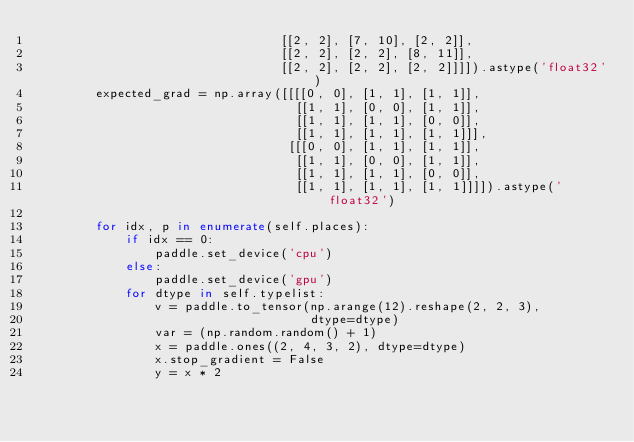<code> <loc_0><loc_0><loc_500><loc_500><_Python_>                                 [[2, 2], [7, 10], [2, 2]],
                                 [[2, 2], [2, 2], [8, 11]],
                                 [[2, 2], [2, 2], [2, 2]]]]).astype('float32')
        expected_grad = np.array([[[[0, 0], [1, 1], [1, 1]],
                                   [[1, 1], [0, 0], [1, 1]],
                                   [[1, 1], [1, 1], [0, 0]],
                                   [[1, 1], [1, 1], [1, 1]]],
                                  [[[0, 0], [1, 1], [1, 1]],
                                   [[1, 1], [0, 0], [1, 1]],
                                   [[1, 1], [1, 1], [0, 0]],
                                   [[1, 1], [1, 1], [1, 1]]]]).astype('float32')

        for idx, p in enumerate(self.places):
            if idx == 0:
                paddle.set_device('cpu')
            else:
                paddle.set_device('gpu')
            for dtype in self.typelist:
                v = paddle.to_tensor(np.arange(12).reshape(2, 2, 3),
                                     dtype=dtype)
                var = (np.random.random() + 1)
                x = paddle.ones((2, 4, 3, 2), dtype=dtype)
                x.stop_gradient = False
                y = x * 2</code> 